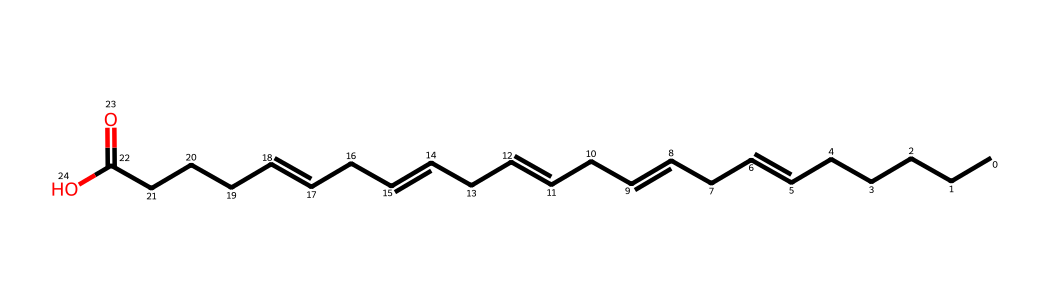What is the total number of carbon atoms in the omega-3 fatty acid represented by the SMILES? In the provided SMILES, count the 'C' characters before any double bond or functional group. There are 18 carbon atoms in total.
Answer: 18 How many double bonds are present in this fatty acid? The SMILES notation indicates the presence of multiple double bonds, which are represented by '='. By counting the '=' symbols, we find that there are 5 double bonds.
Answer: 5 What type of functional group is present at the end of this fatty acid structure? In the SMILES notation, the presence of 'C(=O)O' suggests a carboxylic acid functional group, where the carbon is double-bonded to an oxygen and single-bonded to a hydroxyl group (–COOH).
Answer: carboxylic acid What can be inferred about the saturation of this fatty acid? Due to the presence of multiple double bonds (5 in total), the fatty acid can be classified as unsaturated, indicating that it has fewer hydrogen atoms than a saturated fatty acid with the same number of carbon atoms.
Answer: unsaturated What is the IUPAC name for the fatty acid represented by this SMILES? The structure matches that of α-linolenic acid, which is an omega-3 fatty acid due to its first double bond occurring at the third carbon from the methyl end.
Answer: α-linolenic acid Which type of lipid does this chemical structure represent? Given the carboxylic acid functional group and the long hydrocarbon chain with multiple double bonds, this lipid is categorized as a triglyceride specifically as one of the unsaturated fatty acids typically found in fish oil.
Answer: triglyceride 